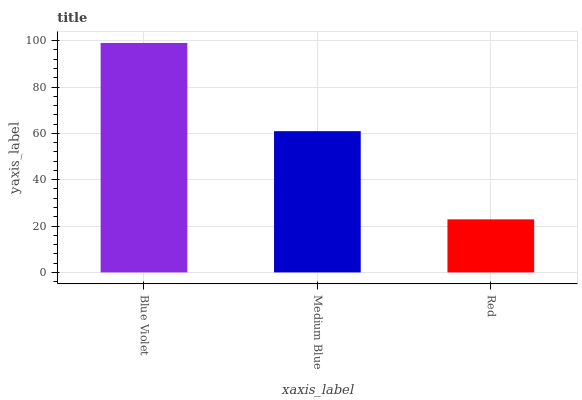Is Red the minimum?
Answer yes or no. Yes. Is Blue Violet the maximum?
Answer yes or no. Yes. Is Medium Blue the minimum?
Answer yes or no. No. Is Medium Blue the maximum?
Answer yes or no. No. Is Blue Violet greater than Medium Blue?
Answer yes or no. Yes. Is Medium Blue less than Blue Violet?
Answer yes or no. Yes. Is Medium Blue greater than Blue Violet?
Answer yes or no. No. Is Blue Violet less than Medium Blue?
Answer yes or no. No. Is Medium Blue the high median?
Answer yes or no. Yes. Is Medium Blue the low median?
Answer yes or no. Yes. Is Red the high median?
Answer yes or no. No. Is Red the low median?
Answer yes or no. No. 